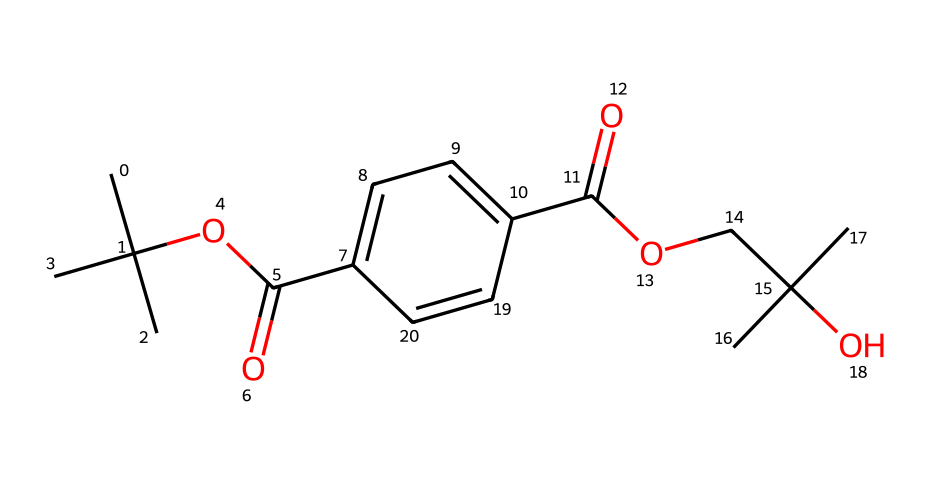What is the main functional group present in this chemical? The chemical structure contains a carboxylic acid group (-COOH) and an ester group (-COOC-), both of which are functional groups that are characteristic of polyethylene terephthalate. The presence of the -COOH indicates a carboxylic acid.
Answer: carboxylic acid How many carbon atoms are in this compound? By counting the carbon (C) atoms in the structure from the SMILES representation, there are a total of 15 carbon atoms present.
Answer: 15 What type of polymerization process forms polyethylene terephthalate? The SMILES representation reveals the presence of ester linkages between carboxylic acid and alcohol groups, clearly indicating that the polymerization process involved is condensation polymerization.
Answer: condensation What functional group is responsible for the solubility of polyethylene terephthalate in organic solvents? The presence of the ester functional group (-COOC-) in the chemical structure allows polyethylene terephthalate to be soluble in organic solvents, due to its polar characteristics.
Answer: ester How many ester linkages are present in this molecule? By examining the structure, it can be seen that there are two ester linkages formed between the alcohol and acid components, highlighting the connectivity in the polymer chain.
Answer: two What type of structure does polyethylene terephthalate primarily have? The structure shows that polyethylene terephthalate forms a linear chain with repetitive ester and aromatic components, indicating that it is a linear thermoplastic polymer.
Answer: linear thermoplastic 